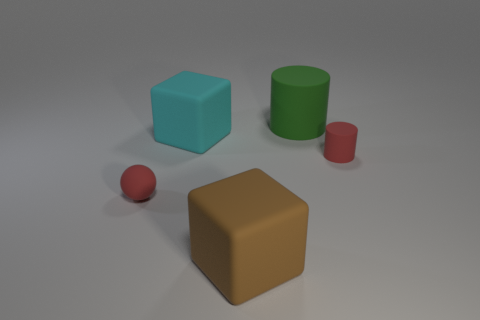Add 2 tiny brown metal blocks. How many objects exist? 7 Subtract all red cylinders. How many cylinders are left? 1 Subtract all spheres. How many objects are left? 4 Subtract 1 cylinders. How many cylinders are left? 1 Subtract all green blocks. Subtract all purple spheres. How many blocks are left? 2 Subtract all red cubes. How many green cylinders are left? 1 Subtract all green cylinders. Subtract all tiny red rubber things. How many objects are left? 2 Add 4 cylinders. How many cylinders are left? 6 Add 5 cyan rubber things. How many cyan rubber things exist? 6 Subtract 0 brown balls. How many objects are left? 5 